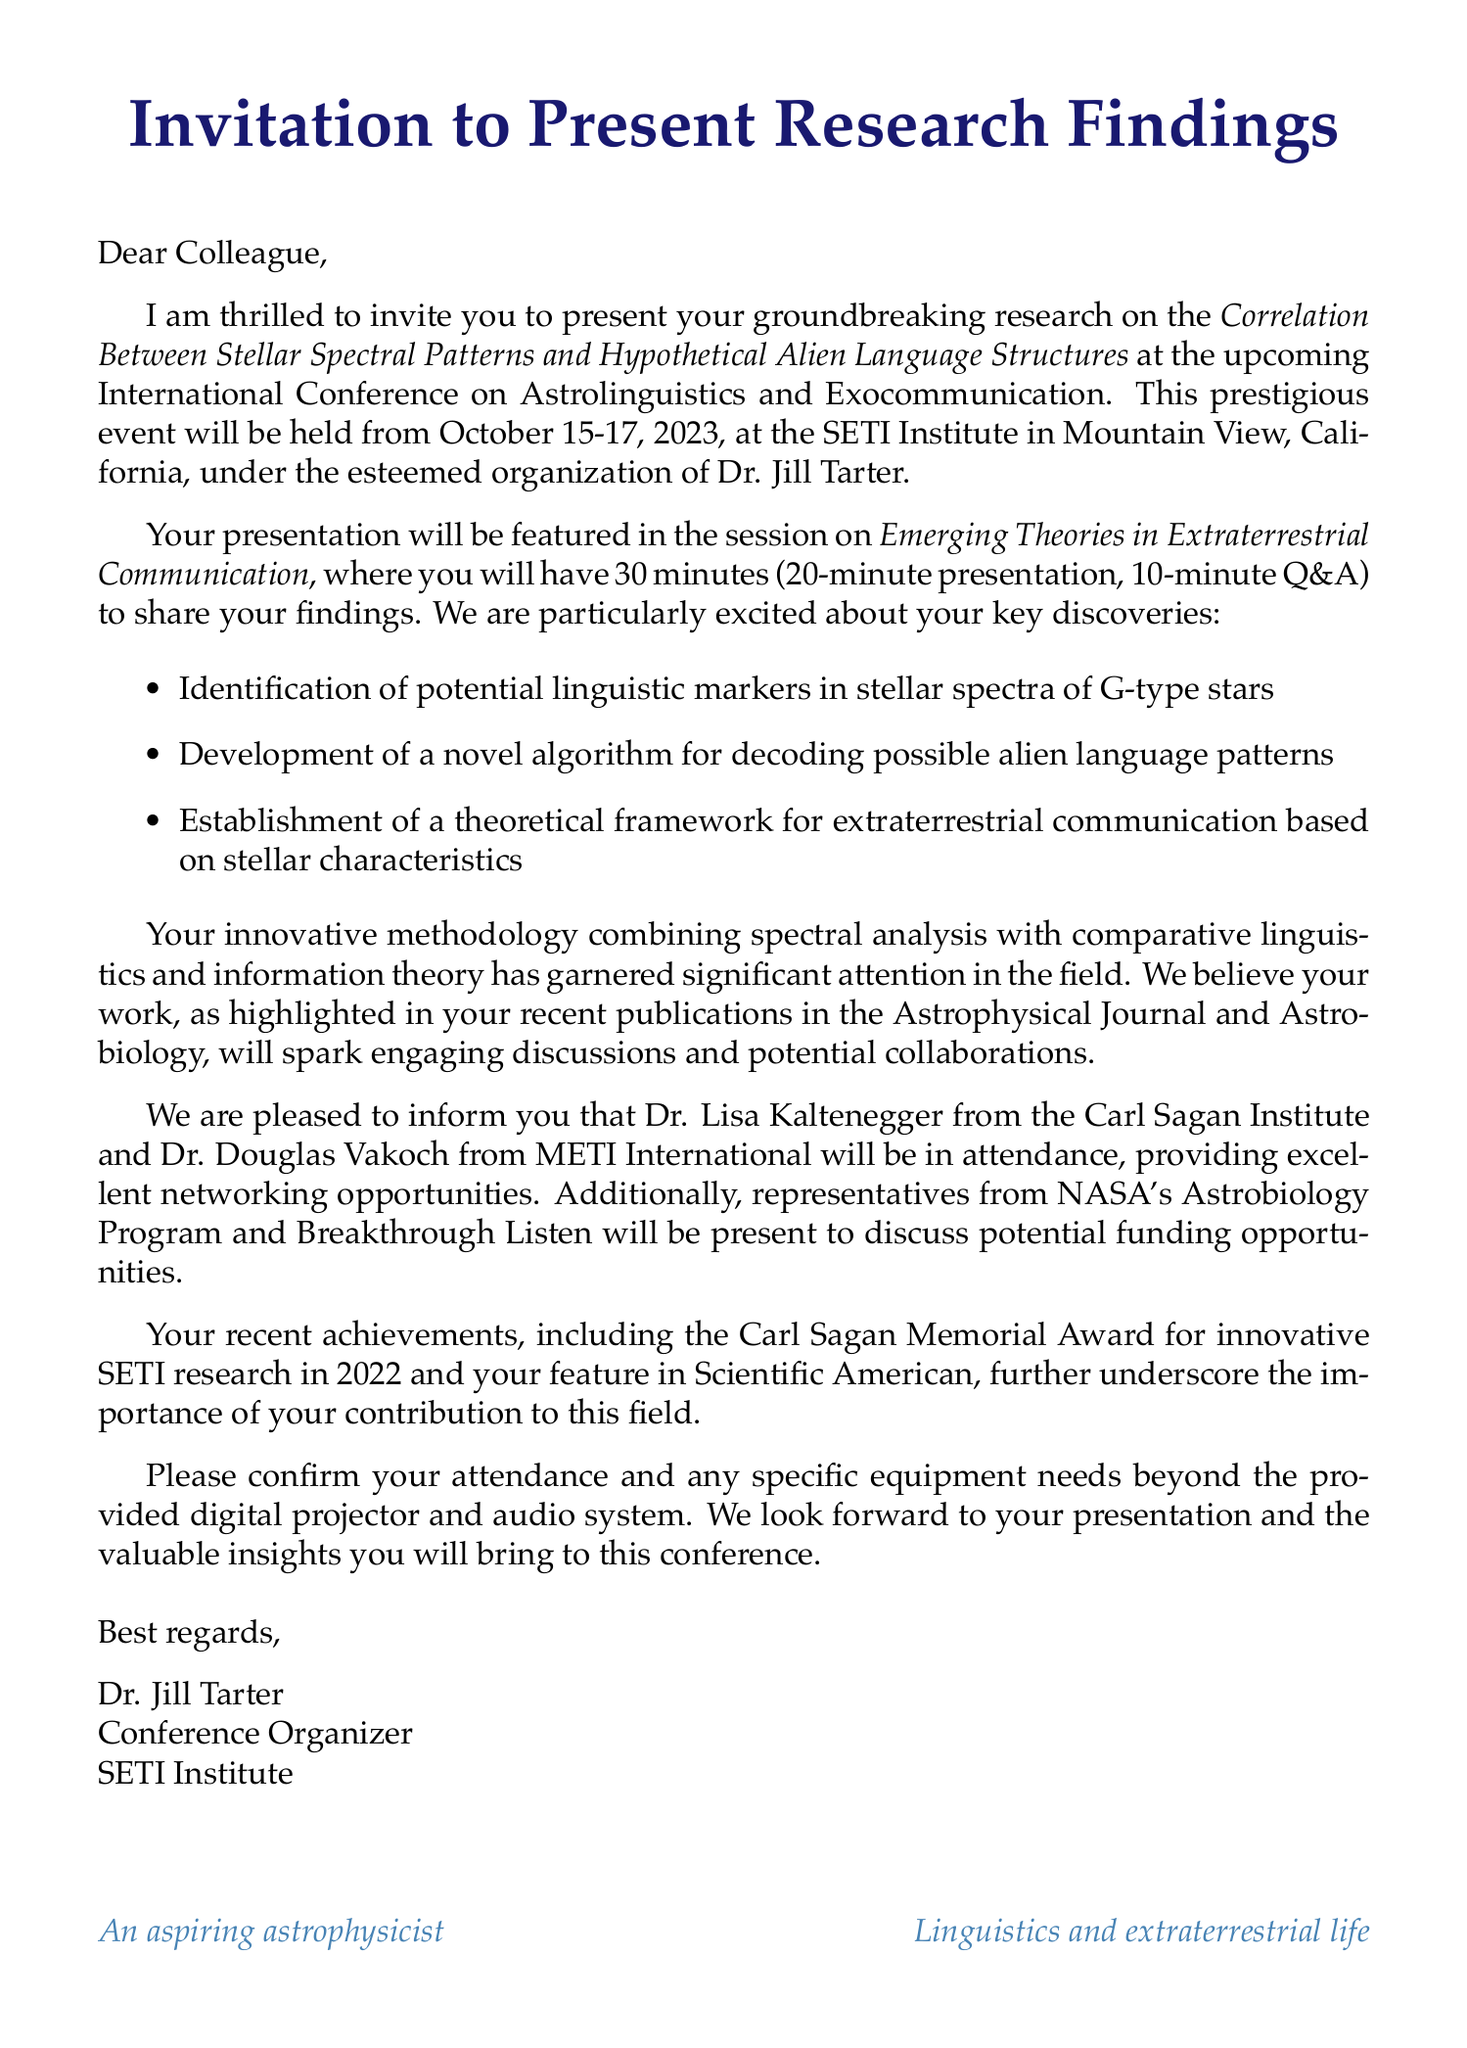What is the name of the conference? The name is listed in the document as the International Conference on Astrolinguistics and Exocommunication.
Answer: International Conference on Astrolinguistics and Exocommunication Who is the organizer of the conference? The document specifies Dr. Jill Tarter as the organizer.
Answer: Dr. Jill Tarter What are the dates of the conference? The document provides the dates as October 15-17, 2023.
Answer: October 15-17, 2023 What is the duration of the presentation? The duration of the presentation is mentioned in the document as 30 minutes.
Answer: 30 minutes How many key findings are listed in the research summary? The document outlines three key findings.
Answer: Three What methodology is used in the research? The methodology combines spectral analysis with comparative linguistics and information theory, as stated in the document.
Answer: Spectral analysis combined with comparative linguistics and information theory Who are the potential collaborators mentioned? The document lists Dr. Lisa Kaltenegger and Dr. Douglas Vakoch as potential collaborators.
Answer: Dr. Lisa Kaltenegger and Dr. Douglas Vakoch What award did the author receive in 2022? The document mentions the Carl Sagan Memorial Award for innovative SETI research received in 2022.
Answer: Carl Sagan Memorial Award What is the deadline for the NASA Astrobiology Program funding opportunity? The document specifies the deadline as December 1, 2023.
Answer: December 1, 2023 